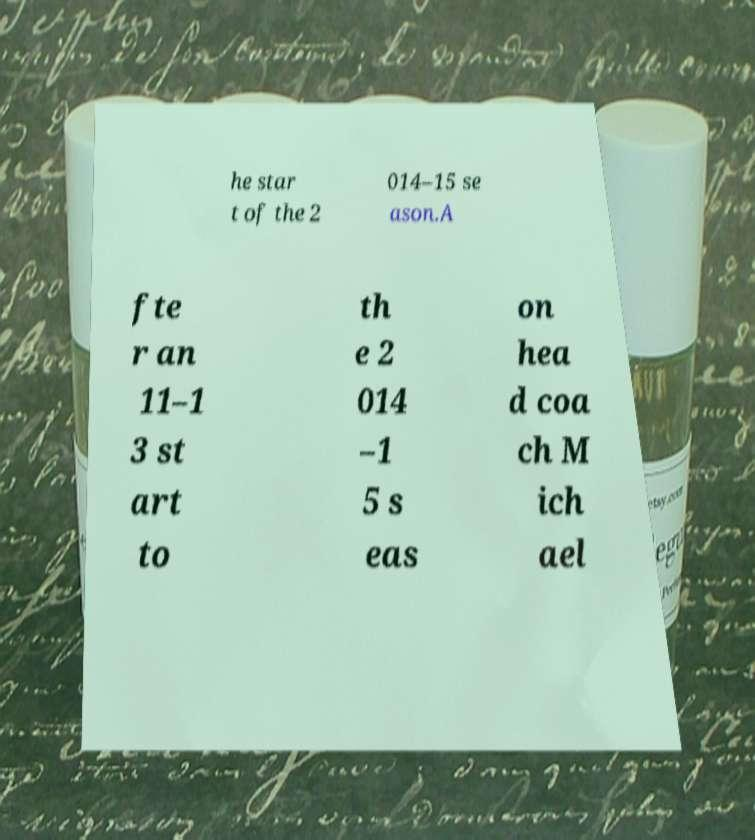I need the written content from this picture converted into text. Can you do that? he star t of the 2 014–15 se ason.A fte r an 11–1 3 st art to th e 2 014 –1 5 s eas on hea d coa ch M ich ael 